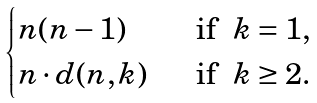<formula> <loc_0><loc_0><loc_500><loc_500>\begin{cases} n ( n - 1 ) & \ \text { if } \ k = 1 , \\ n \cdot d ( n , k ) & \ \text { if } \ k \geq 2 . \end{cases}</formula> 